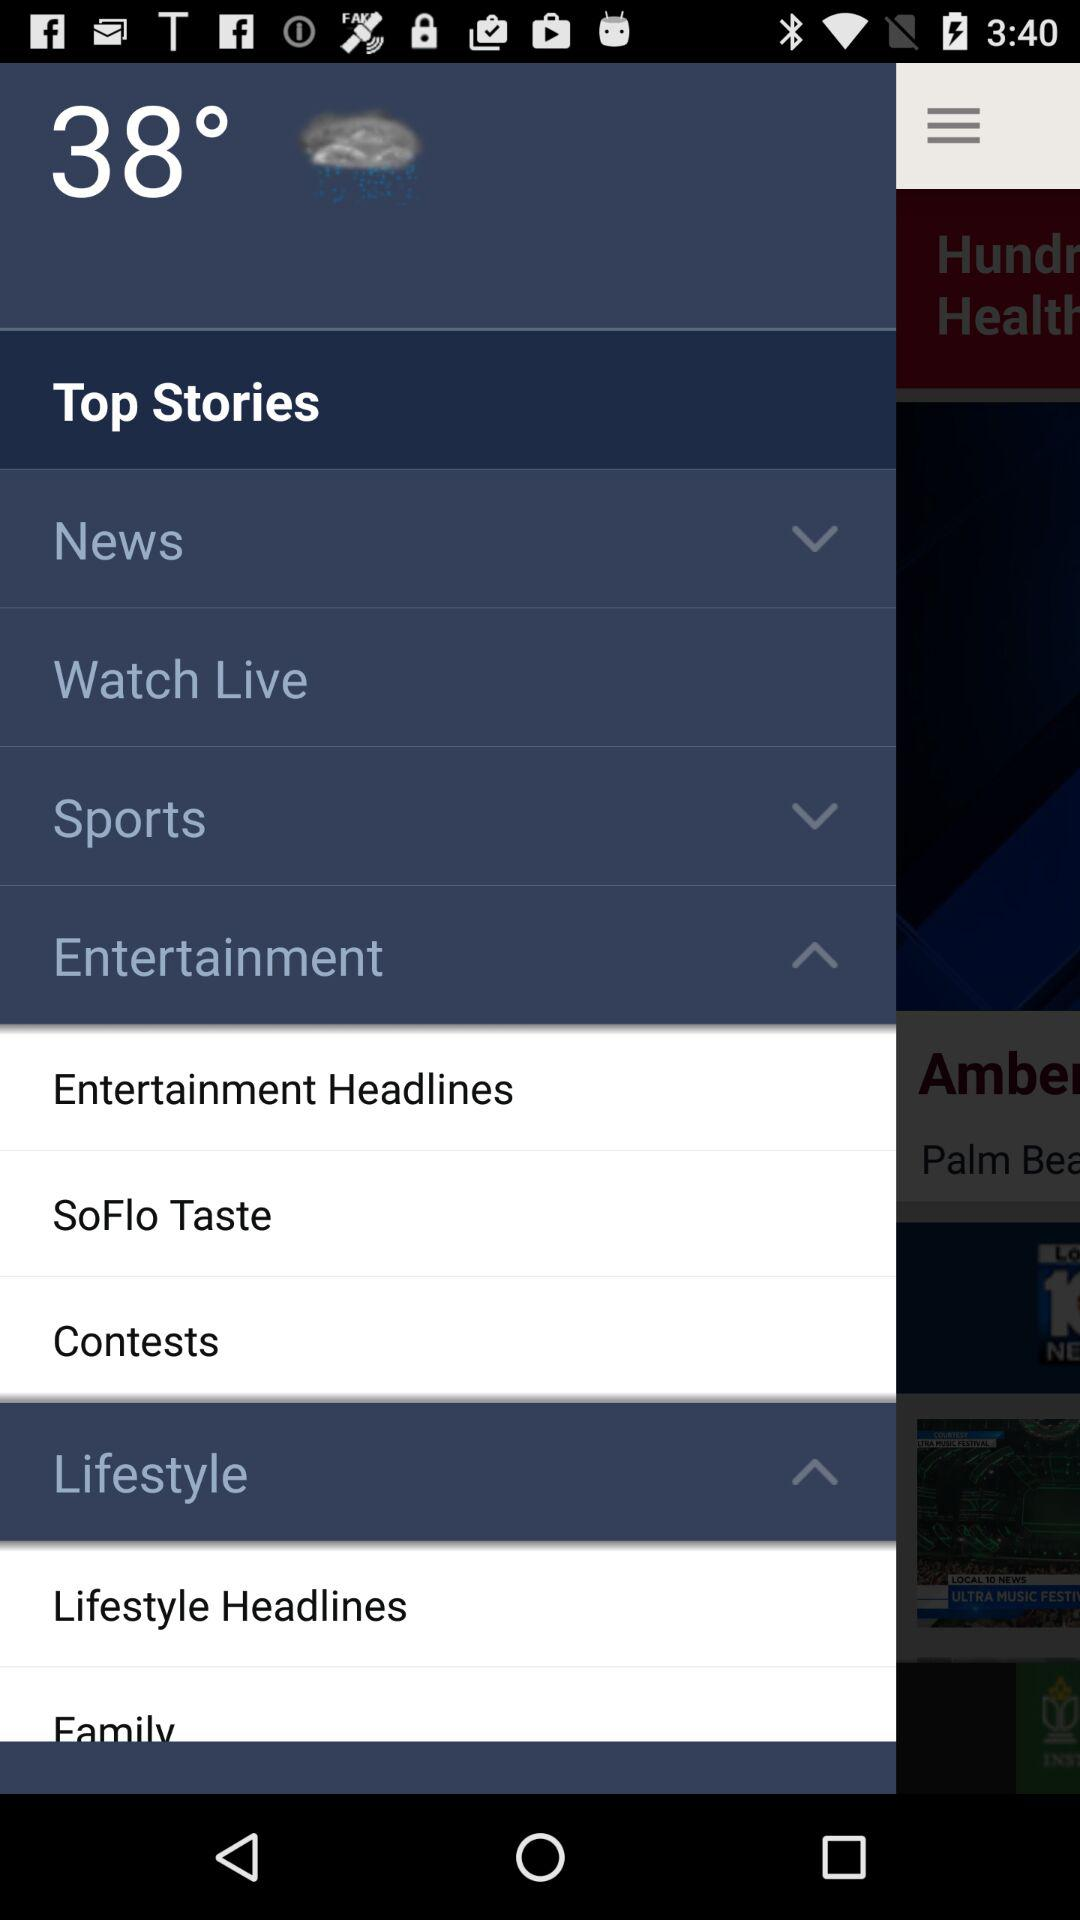How many items have arrows pointing down?
Answer the question using a single word or phrase. 2 